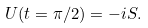<formula> <loc_0><loc_0><loc_500><loc_500>U ( t = \pi / 2 ) = - i S .</formula> 